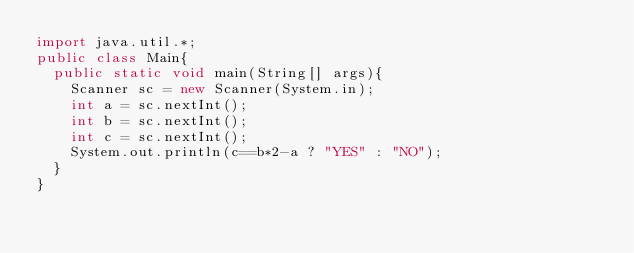<code> <loc_0><loc_0><loc_500><loc_500><_Java_>import java.util.*;
public class Main{
	public static void main(String[] args){
		Scanner sc = new Scanner(System.in);
		int a = sc.nextInt();
		int b = sc.nextInt();
		int c = sc.nextInt();
		System.out.println(c==b*2-a ? "YES" : "NO");
	}
}</code> 